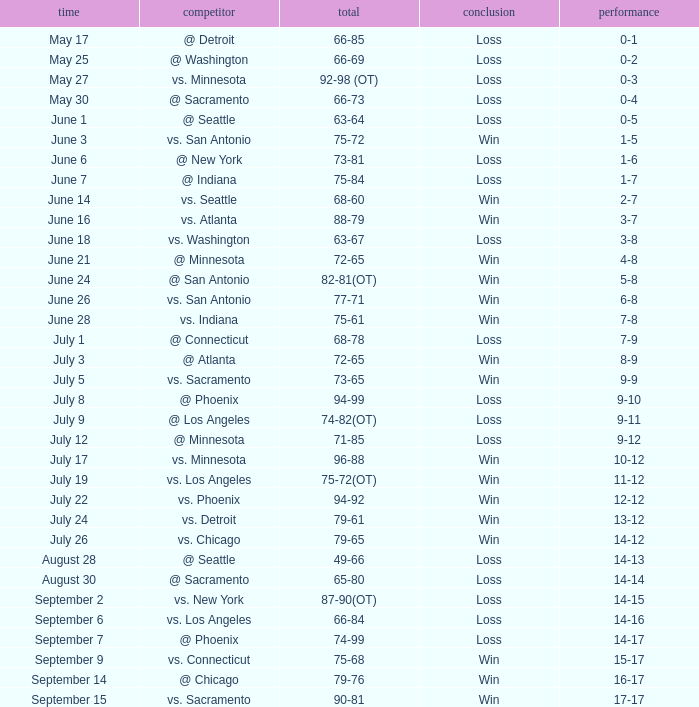What was the Result on May 30? Loss. 